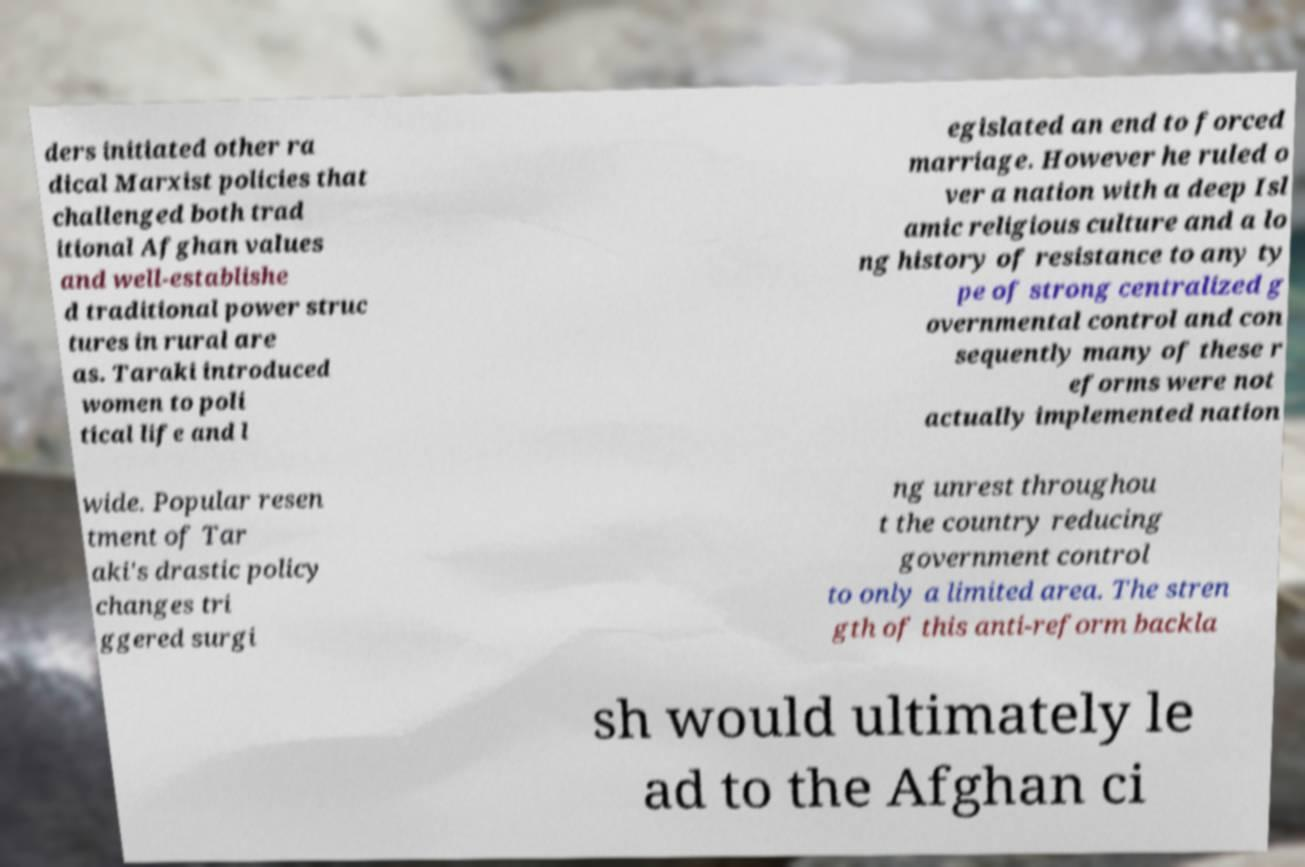What messages or text are displayed in this image? I need them in a readable, typed format. ders initiated other ra dical Marxist policies that challenged both trad itional Afghan values and well-establishe d traditional power struc tures in rural are as. Taraki introduced women to poli tical life and l egislated an end to forced marriage. However he ruled o ver a nation with a deep Isl amic religious culture and a lo ng history of resistance to any ty pe of strong centralized g overnmental control and con sequently many of these r eforms were not actually implemented nation wide. Popular resen tment of Tar aki's drastic policy changes tri ggered surgi ng unrest throughou t the country reducing government control to only a limited area. The stren gth of this anti-reform backla sh would ultimately le ad to the Afghan ci 